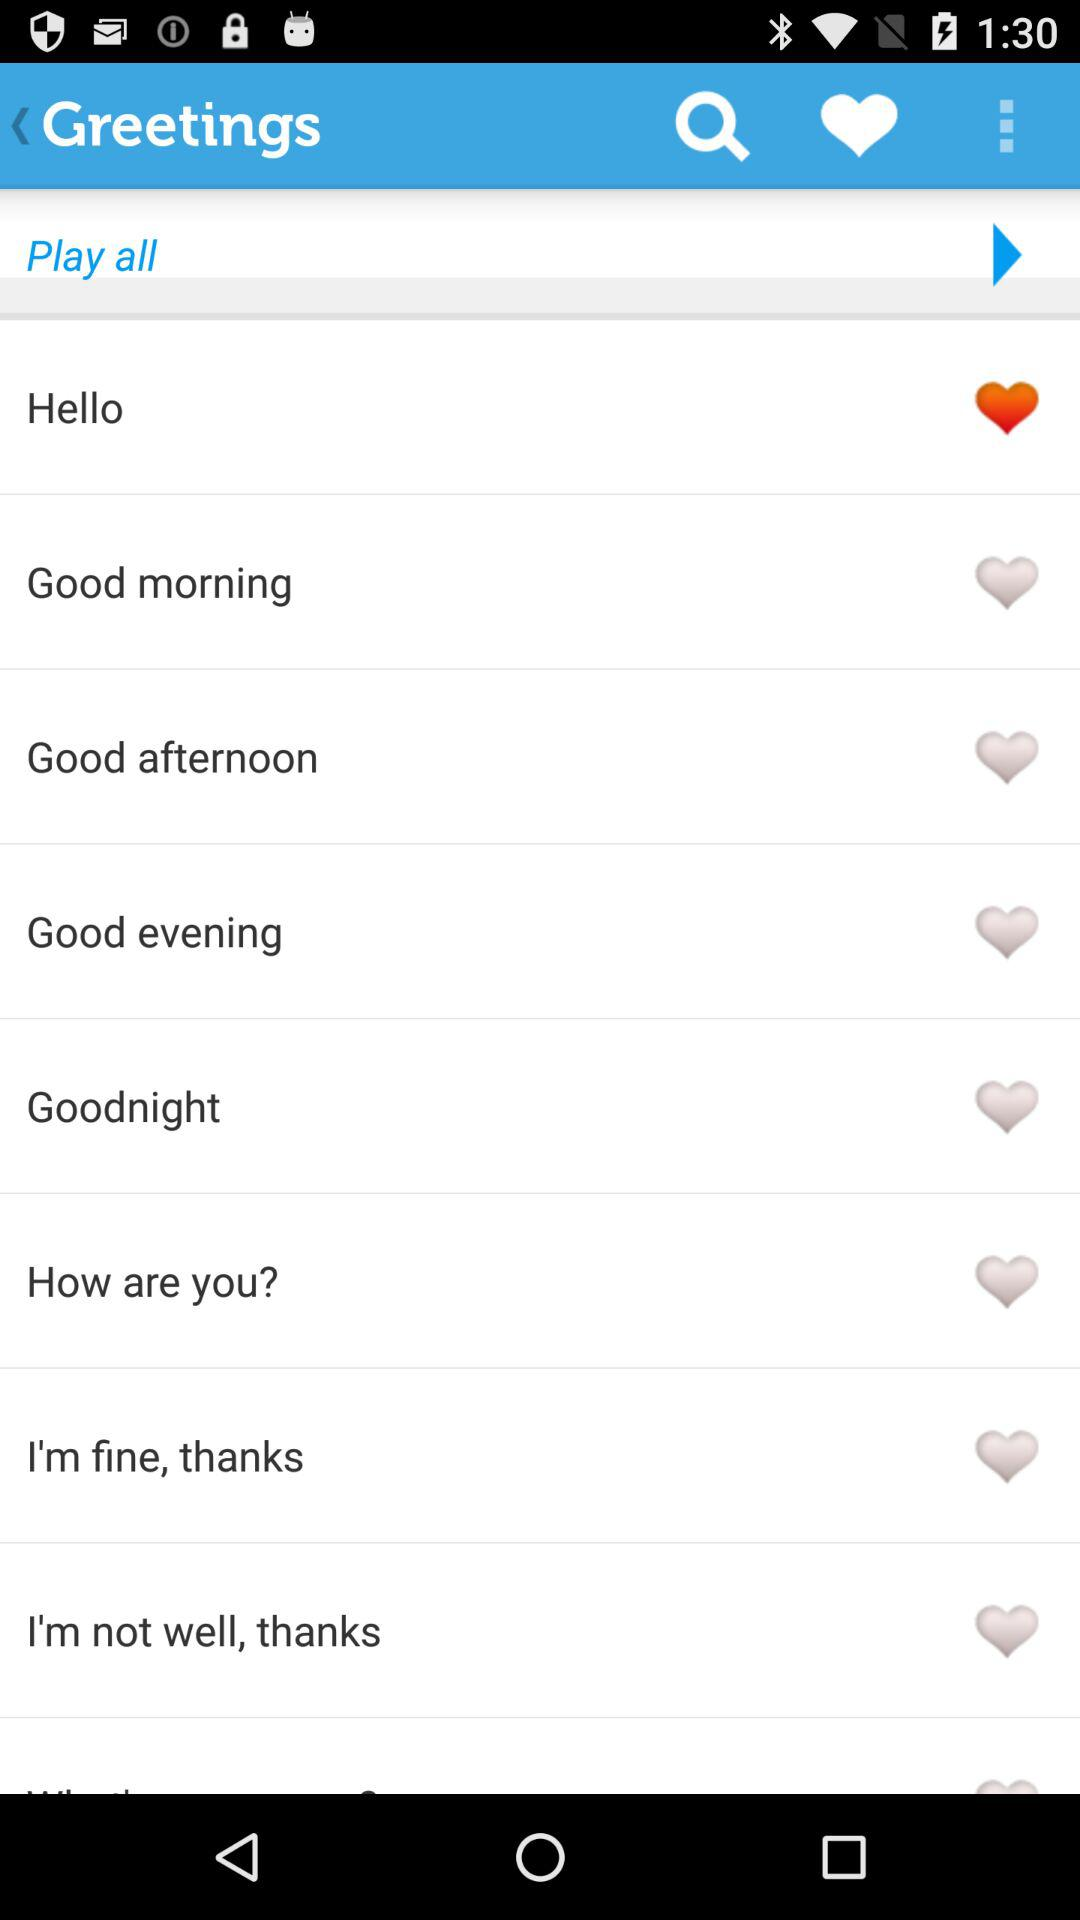Which greeting is marked as a favorite? The greeting that is marked as a favorite is "Hello". 